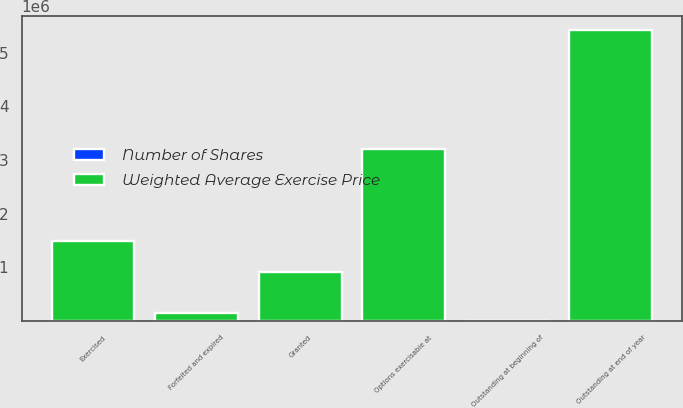Convert chart. <chart><loc_0><loc_0><loc_500><loc_500><stacked_bar_chart><ecel><fcel>Outstanding at beginning of<fcel>Granted<fcel>Exercised<fcel>Forfeited and expired<fcel>Outstanding at end of year<fcel>Options exercisable at<nl><fcel>Weighted Average Exercise Price<fcel>55.68<fcel>918343<fcel>1.49469e+06<fcel>151525<fcel>5.4142e+06<fcel>3.21112e+06<nl><fcel>Number of Shares<fcel>42.65<fcel>55.68<fcel>40.38<fcel>51.02<fcel>45.36<fcel>45.5<nl></chart> 